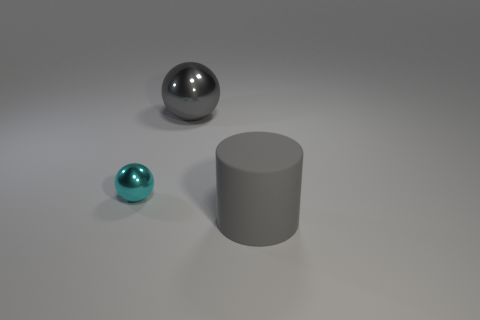There is a large object that is on the left side of the rubber cylinder; is its color the same as the matte cylinder in front of the cyan metal object?
Keep it short and to the point. Yes. There is a object that is in front of the big gray sphere and on the right side of the cyan thing; how big is it?
Your response must be concise. Large. Are there any other small cyan objects made of the same material as the small cyan object?
Ensure brevity in your answer.  No. What material is the big cylinder that is on the right side of the gray thing that is to the left of the large gray rubber cylinder?
Provide a short and direct response. Rubber. How many metallic things are the same color as the big rubber cylinder?
Ensure brevity in your answer.  1. There is a sphere that is the same material as the cyan thing; what size is it?
Give a very brief answer. Large. What is the shape of the big gray object that is in front of the large gray shiny object?
Offer a very short reply. Cylinder. What size is the other metal object that is the same shape as the gray shiny object?
Your answer should be compact. Small. How many gray objects are behind the gray thing in front of the large gray metallic ball behind the big gray cylinder?
Keep it short and to the point. 1. Is the number of gray things behind the big cylinder the same as the number of large gray spheres?
Provide a succinct answer. Yes. 